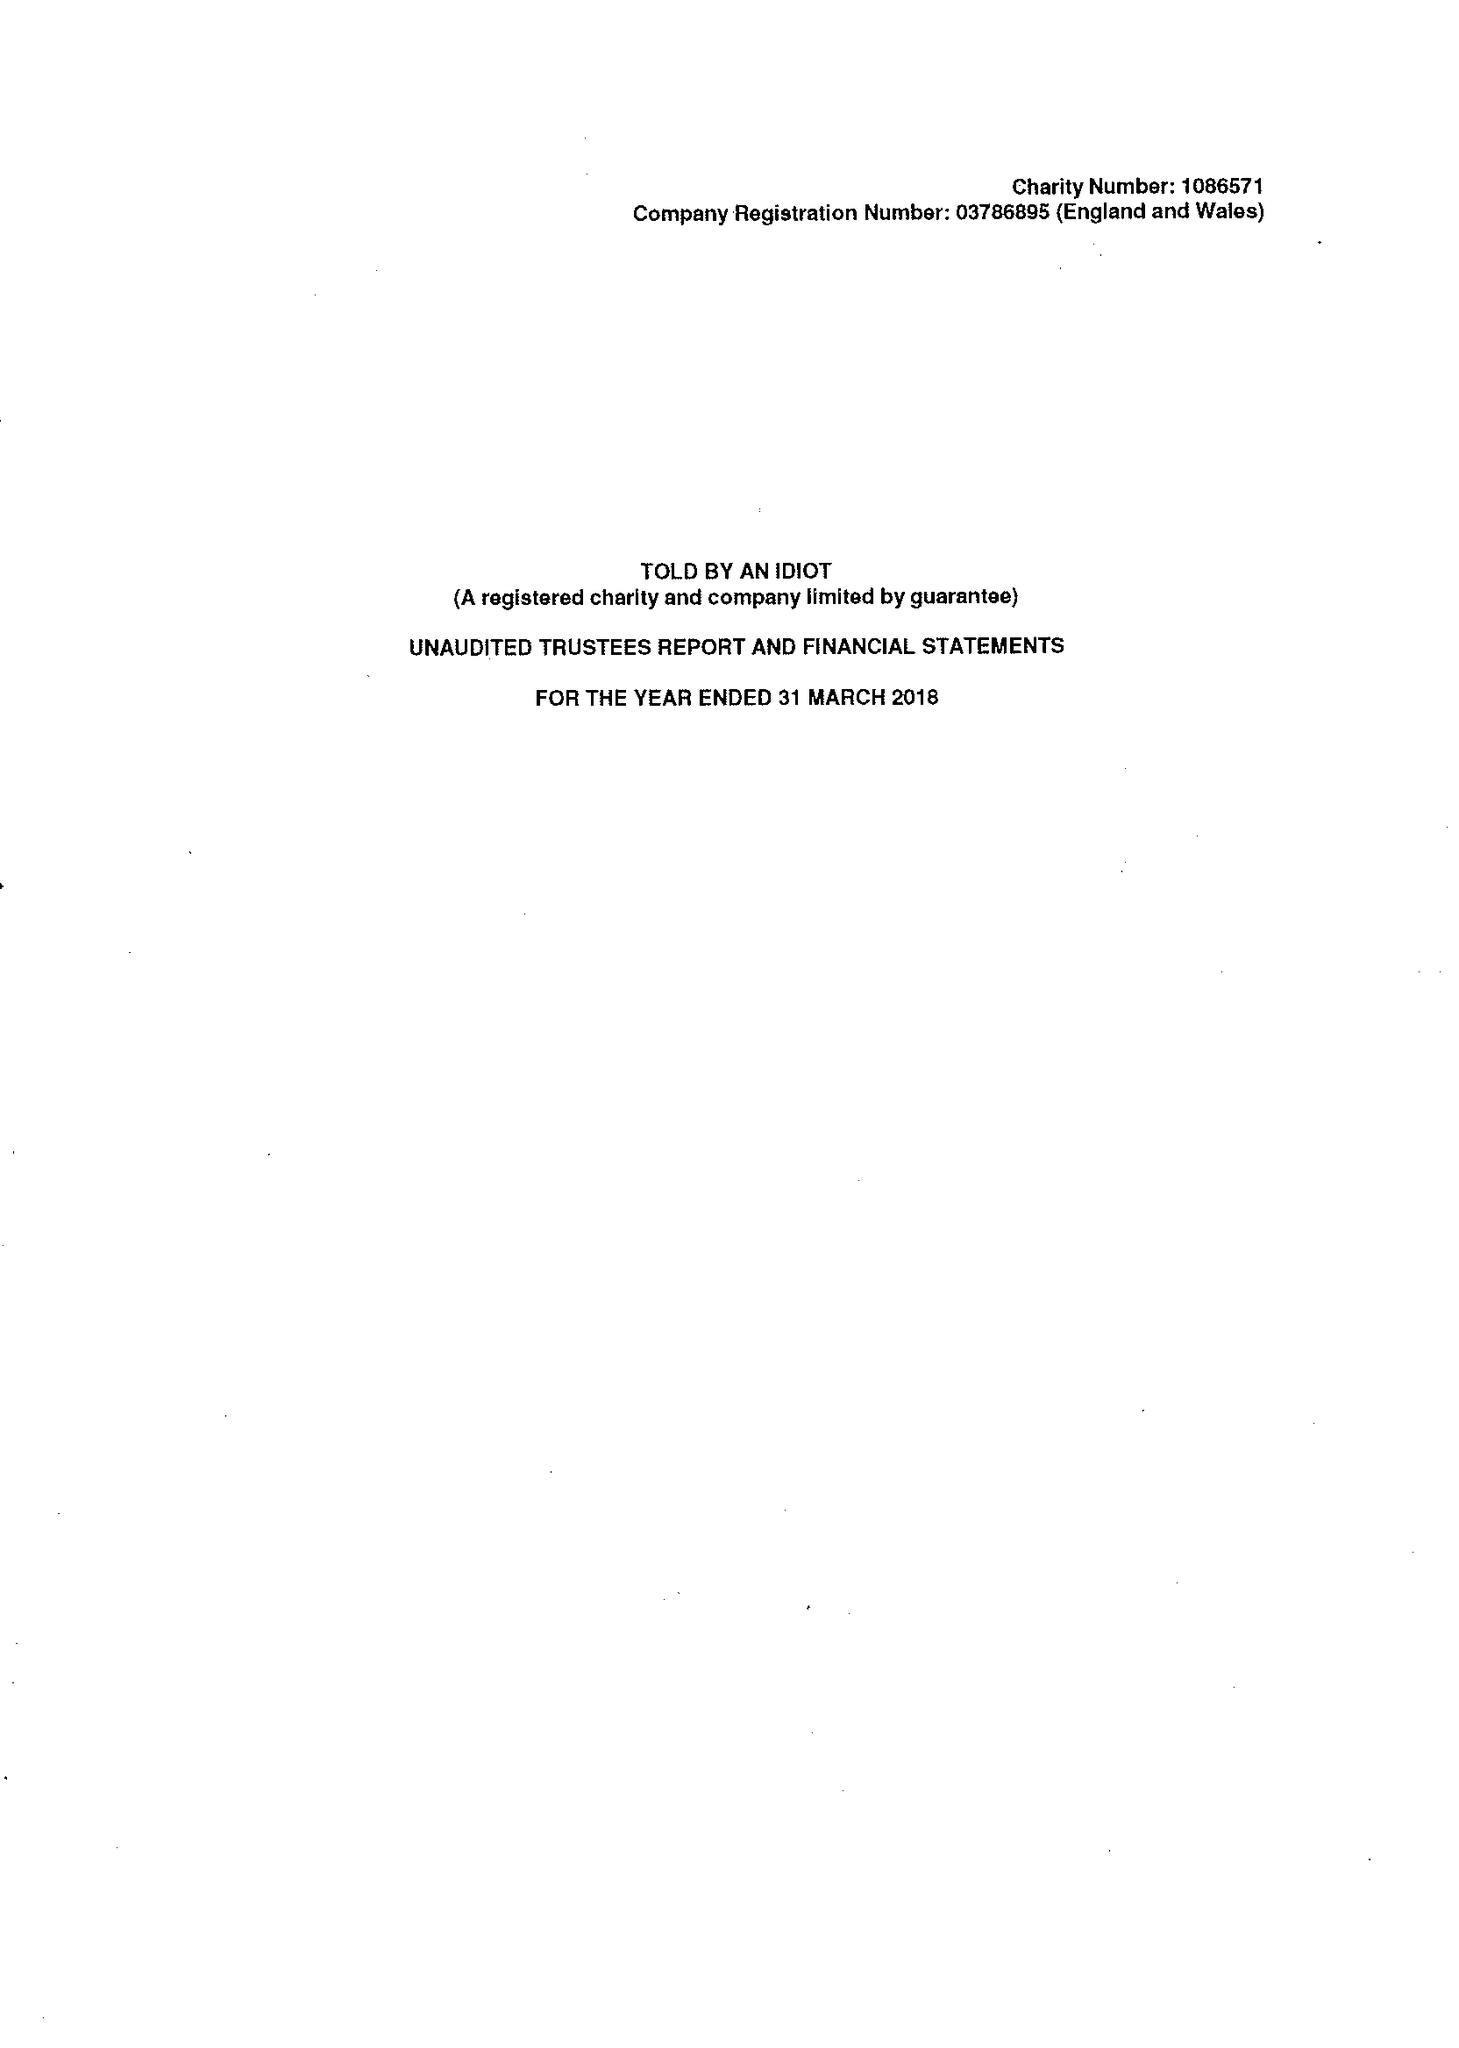What is the value for the charity_name?
Answer the question using a single word or phrase. Told By An Idiot 